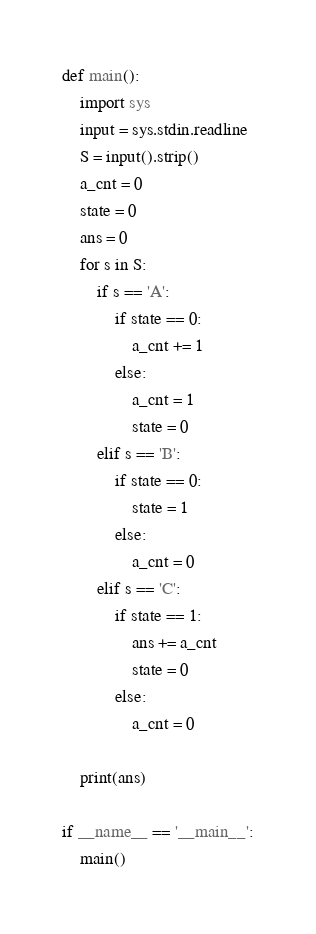Convert code to text. <code><loc_0><loc_0><loc_500><loc_500><_Python_>def main():
    import sys
    input = sys.stdin.readline
    S = input().strip()
    a_cnt = 0
    state = 0
    ans = 0
    for s in S:
        if s == 'A':
            if state == 0:
                a_cnt += 1
            else:
                a_cnt = 1
                state = 0
        elif s == 'B':
            if state == 0:
                state = 1
            else:
                a_cnt = 0
        elif s == 'C':
            if state == 1:
                ans += a_cnt
                state = 0
            else:
                a_cnt = 0

    print(ans)

if __name__ == '__main__':
    main()</code> 